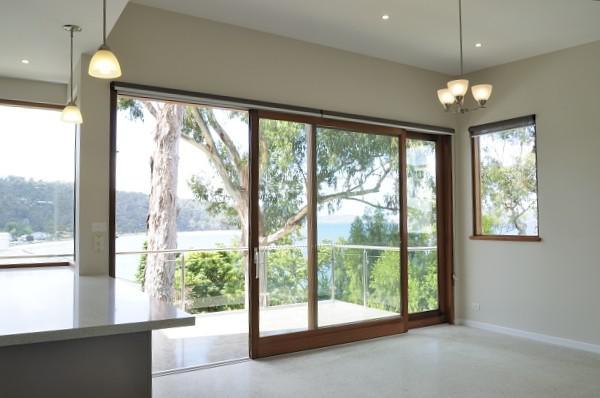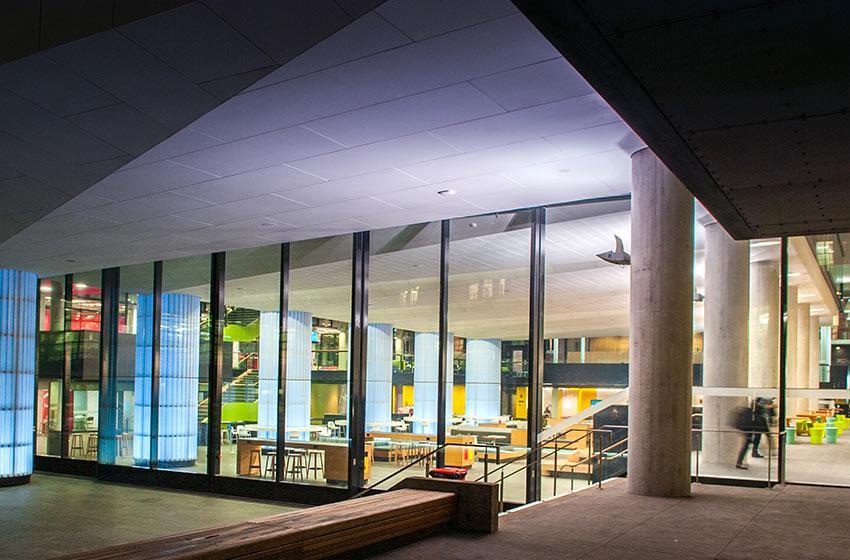The first image is the image on the left, the second image is the image on the right. Given the left and right images, does the statement "The right image shows columns wth cap tops next to a wall of sliding glass doors and glass windows." hold true? Answer yes or no. Yes. The first image is the image on the left, the second image is the image on the right. Considering the images on both sides, is "Doors are open in both images." valid? Answer yes or no. No. 